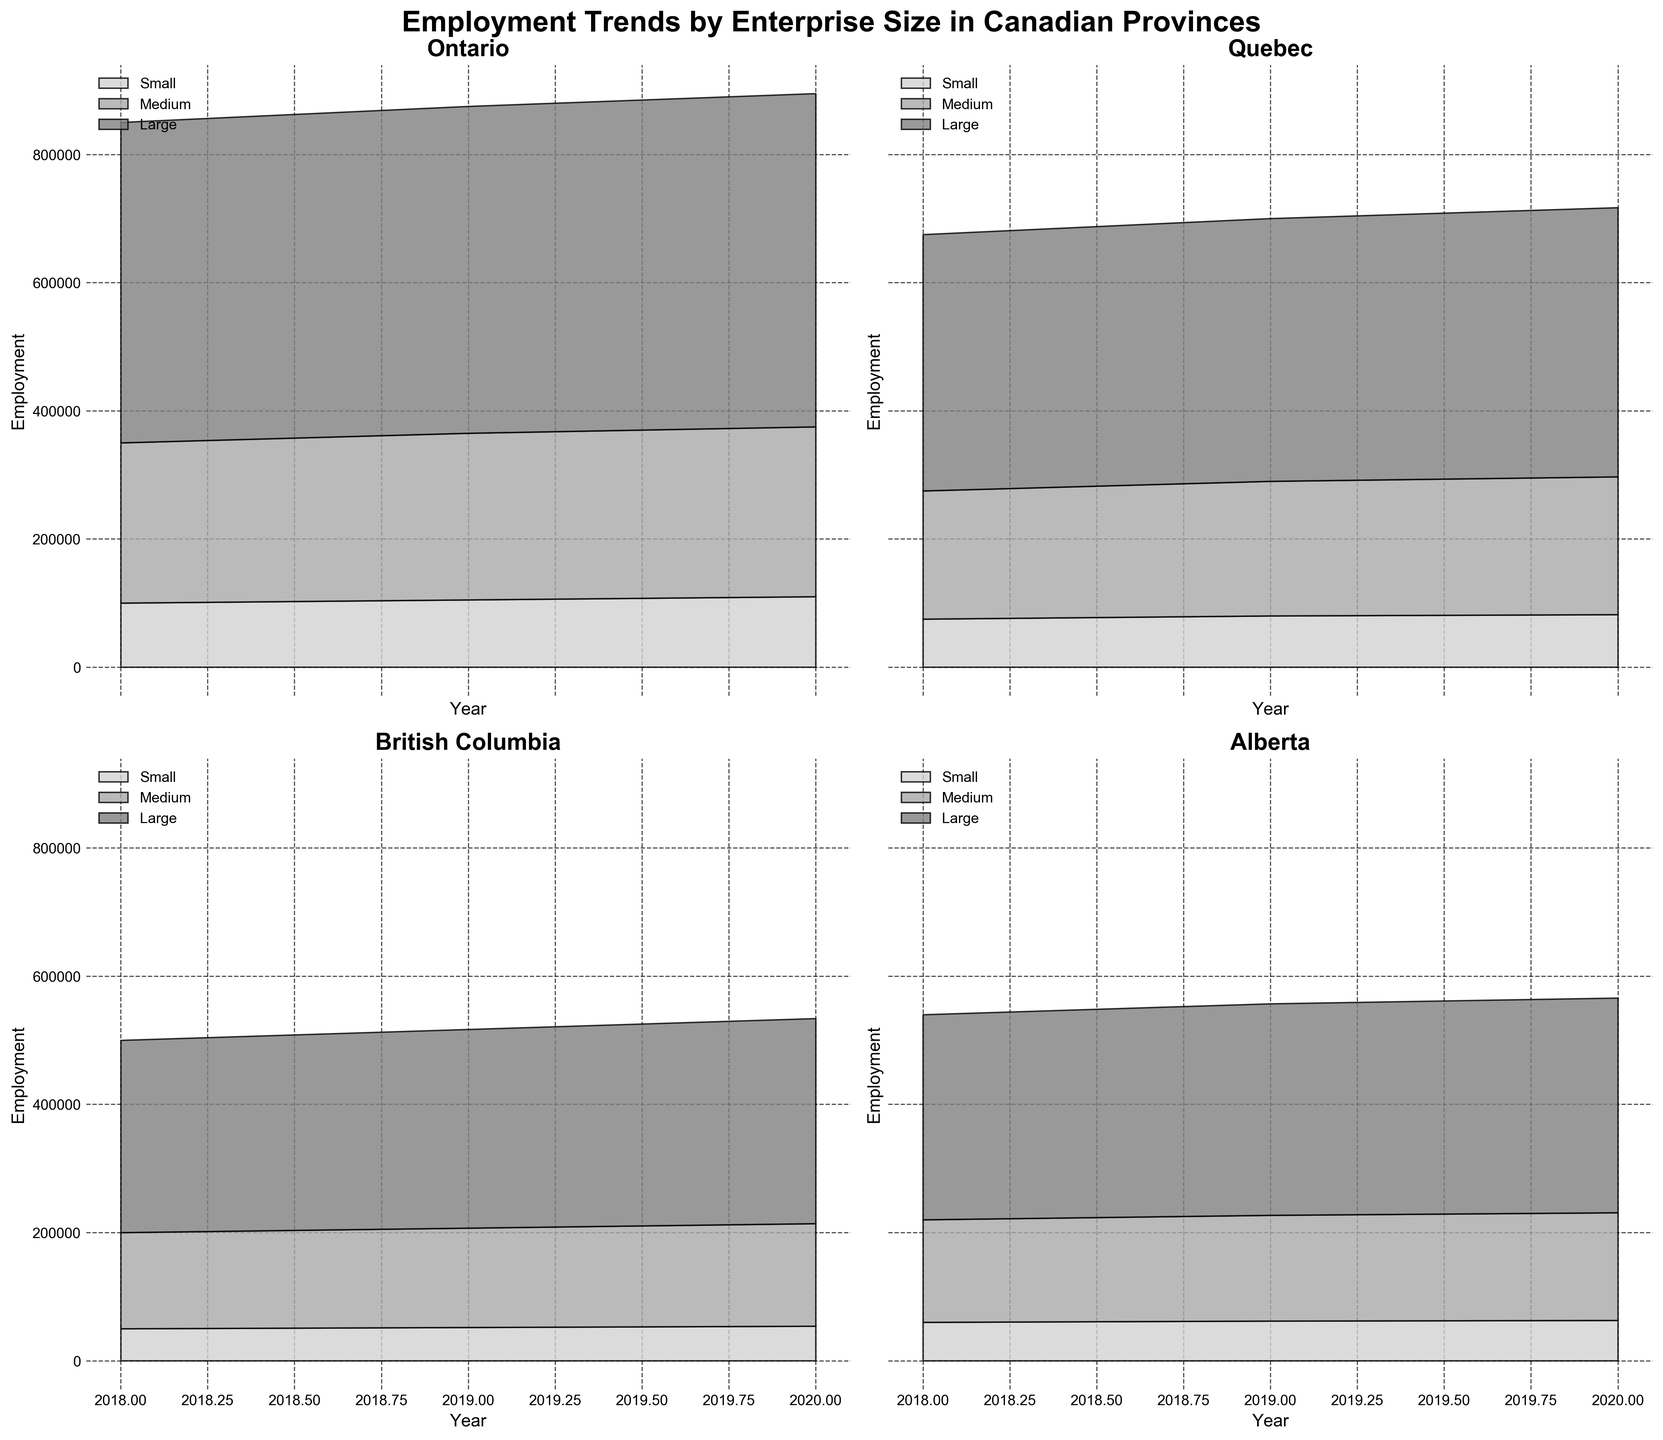Which province had the highest employment in 2020 across all enterprise sizes? By looking at the top edge of each area chart, it's clear that Ontario's combined employment (sum of small, medium, and large enterprises) was the highest in 2020.
Answer: Ontario Between 2018 and 2020, which province showed the biggest increase in employment for small enterprises? Based on the first layer of each area chart, Ontario increased from 100,000 in 2018 to 110,000 in 2020, which is an increase of 10,000. Quebec increased from 75,000 to 82,000 (an increase of 7,000). British Columbia from 50,000 to 54,000 (4,000). Alberta from 60,000 to 63,000 (3,000). Thus, Ontario has the largest increase in small enterprises employment.
Answer: Ontario How did medium-sized enterprise employment in British Columbia change from 2018 to 2019? In the British Columbia subplot, focusing on the middle layer, the medium-sized enterprises' employment went from 150,000 in 2018 to 155,000 in 2019, an increase of 5,000.
Answer: Increased by 5,000 What is the overall trend for large enterprises in Alberta from 2018 to 2020? Observing the topmost layer of the Alberta subplot, large enterprise employment consistently increased from 320,000 in 2018 to 335,000 in 2020.
Answer: Increased trend Which province had the smallest total employment in 2019? By comparing the tops of the area charts for 2019, British Columbia had the smallest total employment, lower than Ontario, Quebec, and Alberta.
Answer: British Columbia In 2020, what was the difference in total employment between Quebec and Alberta? Summing up the layers in each area chart for 2020, Quebec has 82,000 (small) + 215,000 (medium) + 420,000 (large) = 717,000. Alberta has 63,000 (small) + 168,000 (medium) + 335,000 (large) = 566,000. The difference is 717,000 - 566,000 = 151,000.
Answer: 151,000 Which year saw the highest employment for Ontario's medium-sized enterprises? In the Ontario subplot, the middle layer representing medium-sized enterprises shows the highest point in 2020 with 265,000.
Answer: 2020 Are small enterprises more significant in terms of employment in any year or province compared to medium or large enterprises? In all subplots and years, small enterprises contribute less employment in comparison to medium and large enterprises.
Answer: No What is the combined employment for small and medium enterprises in Quebec in 2020? Adding the first and second layers from the Quebec subplot in 2020, small (82,000) + medium (215,000) equals 82,000 + 215,000 = 297,000.
Answer: 297,000 